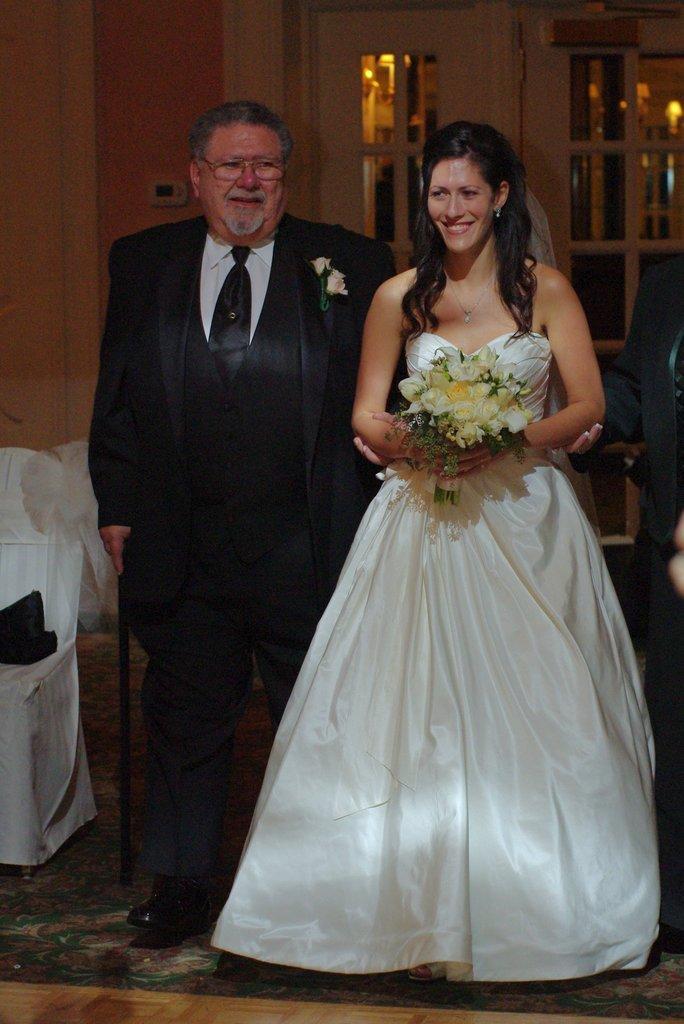Please provide a concise description of this image. The girl in white dress is holding a flower bouquet in her hands. She is walking. Beside her, the man in black blazer is also walking. Both of them are smiling. Beside him, we see a chair. In the background, we see a wall and a door. This picture might be clicked in the banquet hall. 